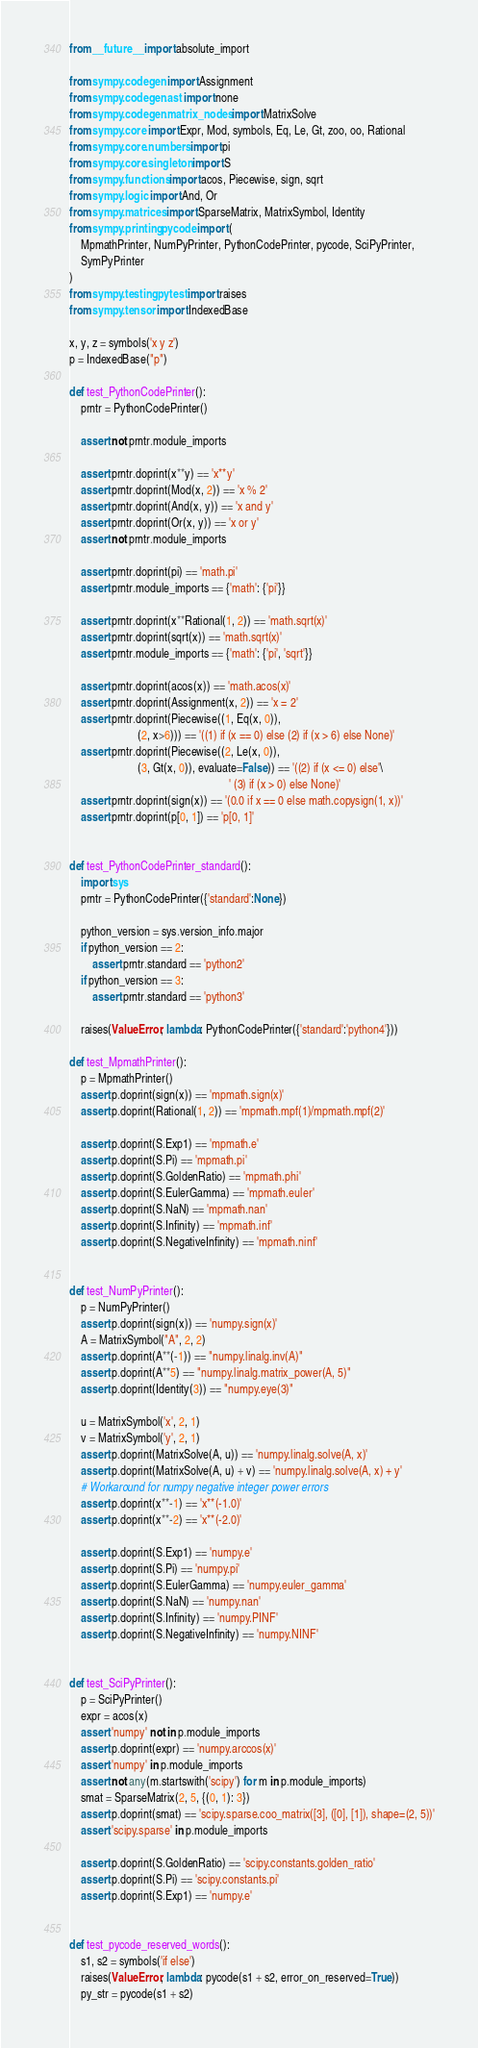<code> <loc_0><loc_0><loc_500><loc_500><_Python_>from __future__ import absolute_import

from sympy.codegen import Assignment
from sympy.codegen.ast import none
from sympy.codegen.matrix_nodes import MatrixSolve
from sympy.core import Expr, Mod, symbols, Eq, Le, Gt, zoo, oo, Rational
from sympy.core.numbers import pi
from sympy.core.singleton import S
from sympy.functions import acos, Piecewise, sign, sqrt
from sympy.logic import And, Or
from sympy.matrices import SparseMatrix, MatrixSymbol, Identity
from sympy.printing.pycode import (
    MpmathPrinter, NumPyPrinter, PythonCodePrinter, pycode, SciPyPrinter,
    SymPyPrinter
)
from sympy.testing.pytest import raises
from sympy.tensor import IndexedBase

x, y, z = symbols('x y z')
p = IndexedBase("p")

def test_PythonCodePrinter():
    prntr = PythonCodePrinter()

    assert not prntr.module_imports

    assert prntr.doprint(x**y) == 'x**y'
    assert prntr.doprint(Mod(x, 2)) == 'x % 2'
    assert prntr.doprint(And(x, y)) == 'x and y'
    assert prntr.doprint(Or(x, y)) == 'x or y'
    assert not prntr.module_imports

    assert prntr.doprint(pi) == 'math.pi'
    assert prntr.module_imports == {'math': {'pi'}}

    assert prntr.doprint(x**Rational(1, 2)) == 'math.sqrt(x)'
    assert prntr.doprint(sqrt(x)) == 'math.sqrt(x)'
    assert prntr.module_imports == {'math': {'pi', 'sqrt'}}

    assert prntr.doprint(acos(x)) == 'math.acos(x)'
    assert prntr.doprint(Assignment(x, 2)) == 'x = 2'
    assert prntr.doprint(Piecewise((1, Eq(x, 0)),
                        (2, x>6))) == '((1) if (x == 0) else (2) if (x > 6) else None)'
    assert prntr.doprint(Piecewise((2, Le(x, 0)),
                        (3, Gt(x, 0)), evaluate=False)) == '((2) if (x <= 0) else'\
                                                        ' (3) if (x > 0) else None)'
    assert prntr.doprint(sign(x)) == '(0.0 if x == 0 else math.copysign(1, x))'
    assert prntr.doprint(p[0, 1]) == 'p[0, 1]'


def test_PythonCodePrinter_standard():
    import sys
    prntr = PythonCodePrinter({'standard':None})

    python_version = sys.version_info.major
    if python_version == 2:
        assert prntr.standard == 'python2'
    if python_version == 3:
        assert prntr.standard == 'python3'

    raises(ValueError, lambda: PythonCodePrinter({'standard':'python4'}))

def test_MpmathPrinter():
    p = MpmathPrinter()
    assert p.doprint(sign(x)) == 'mpmath.sign(x)'
    assert p.doprint(Rational(1, 2)) == 'mpmath.mpf(1)/mpmath.mpf(2)'

    assert p.doprint(S.Exp1) == 'mpmath.e'
    assert p.doprint(S.Pi) == 'mpmath.pi'
    assert p.doprint(S.GoldenRatio) == 'mpmath.phi'
    assert p.doprint(S.EulerGamma) == 'mpmath.euler'
    assert p.doprint(S.NaN) == 'mpmath.nan'
    assert p.doprint(S.Infinity) == 'mpmath.inf'
    assert p.doprint(S.NegativeInfinity) == 'mpmath.ninf'


def test_NumPyPrinter():
    p = NumPyPrinter()
    assert p.doprint(sign(x)) == 'numpy.sign(x)'
    A = MatrixSymbol("A", 2, 2)
    assert p.doprint(A**(-1)) == "numpy.linalg.inv(A)"
    assert p.doprint(A**5) == "numpy.linalg.matrix_power(A, 5)"
    assert p.doprint(Identity(3)) == "numpy.eye(3)"

    u = MatrixSymbol('x', 2, 1)
    v = MatrixSymbol('y', 2, 1)
    assert p.doprint(MatrixSolve(A, u)) == 'numpy.linalg.solve(A, x)'
    assert p.doprint(MatrixSolve(A, u) + v) == 'numpy.linalg.solve(A, x) + y'
    # Workaround for numpy negative integer power errors
    assert p.doprint(x**-1) == 'x**(-1.0)'
    assert p.doprint(x**-2) == 'x**(-2.0)'

    assert p.doprint(S.Exp1) == 'numpy.e'
    assert p.doprint(S.Pi) == 'numpy.pi'
    assert p.doprint(S.EulerGamma) == 'numpy.euler_gamma'
    assert p.doprint(S.NaN) == 'numpy.nan'
    assert p.doprint(S.Infinity) == 'numpy.PINF'
    assert p.doprint(S.NegativeInfinity) == 'numpy.NINF'


def test_SciPyPrinter():
    p = SciPyPrinter()
    expr = acos(x)
    assert 'numpy' not in p.module_imports
    assert p.doprint(expr) == 'numpy.arccos(x)'
    assert 'numpy' in p.module_imports
    assert not any(m.startswith('scipy') for m in p.module_imports)
    smat = SparseMatrix(2, 5, {(0, 1): 3})
    assert p.doprint(smat) == 'scipy.sparse.coo_matrix([3], ([0], [1]), shape=(2, 5))'
    assert 'scipy.sparse' in p.module_imports

    assert p.doprint(S.GoldenRatio) == 'scipy.constants.golden_ratio'
    assert p.doprint(S.Pi) == 'scipy.constants.pi'
    assert p.doprint(S.Exp1) == 'numpy.e'


def test_pycode_reserved_words():
    s1, s2 = symbols('if else')
    raises(ValueError, lambda: pycode(s1 + s2, error_on_reserved=True))
    py_str = pycode(s1 + s2)</code> 